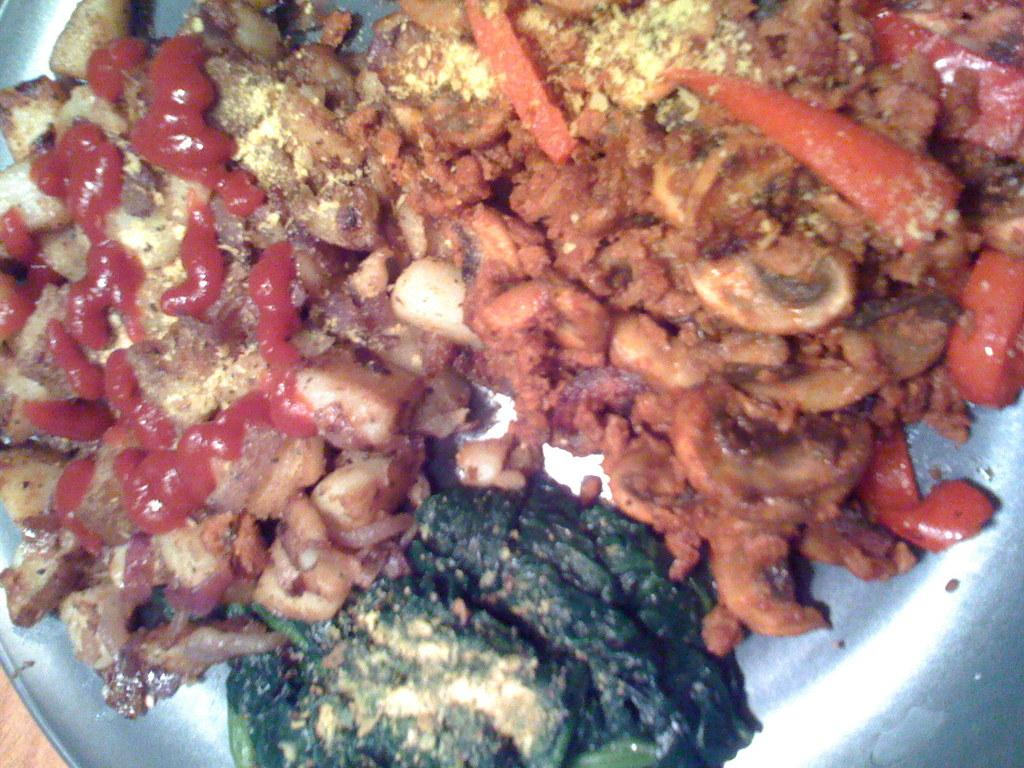What is present on the plate in the image? There is a food item on the plate in the image. Can you describe the food item on the plate? Unfortunately, the specific food item cannot be determined from the provided facts. How many tickets are visible on the plate in the image? There are no tickets present on the plate in the image. What type of cushion is placed under the plate in the image? There is no cushion present under the plate in the image. 